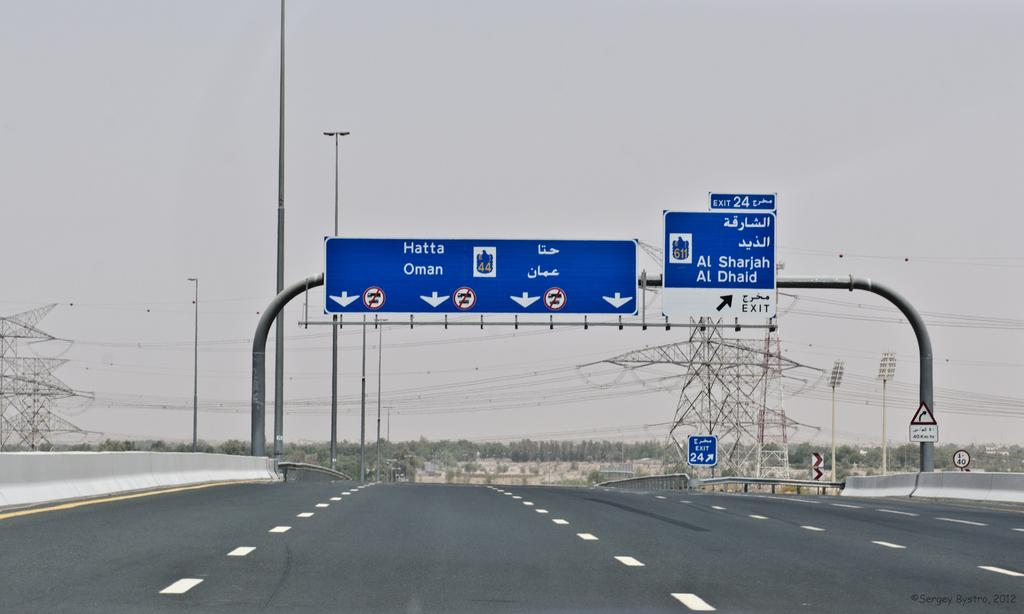<image>
Render a clear and concise summary of the photo. street signs on where to go for Hatta Oman 